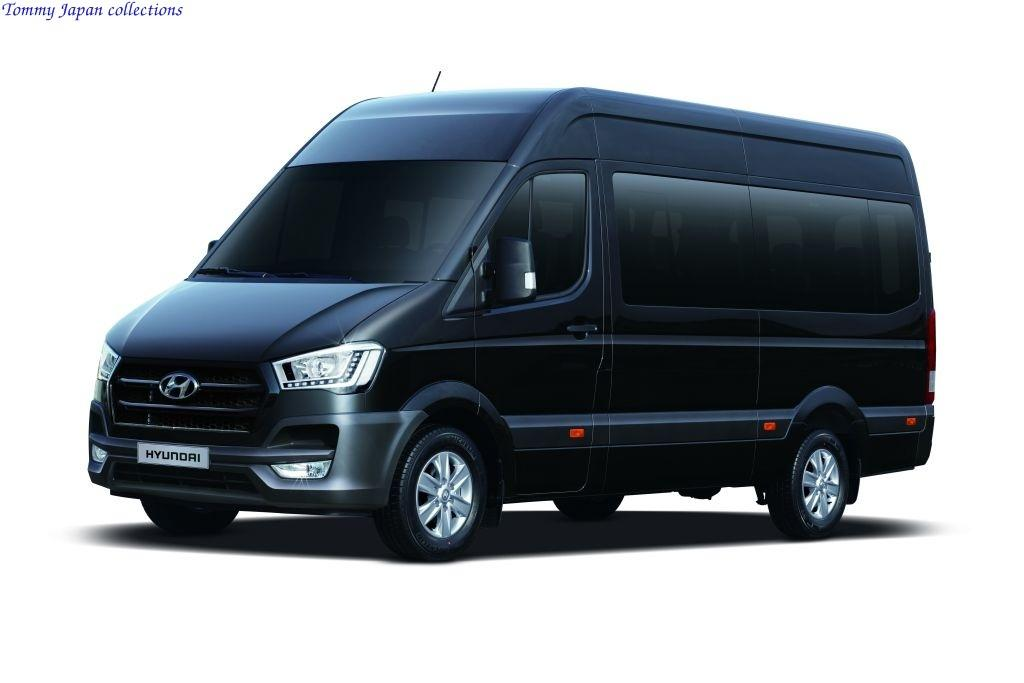<image>
Describe the image concisely. A large black Hyundai work van by Tommy Japan collections. 